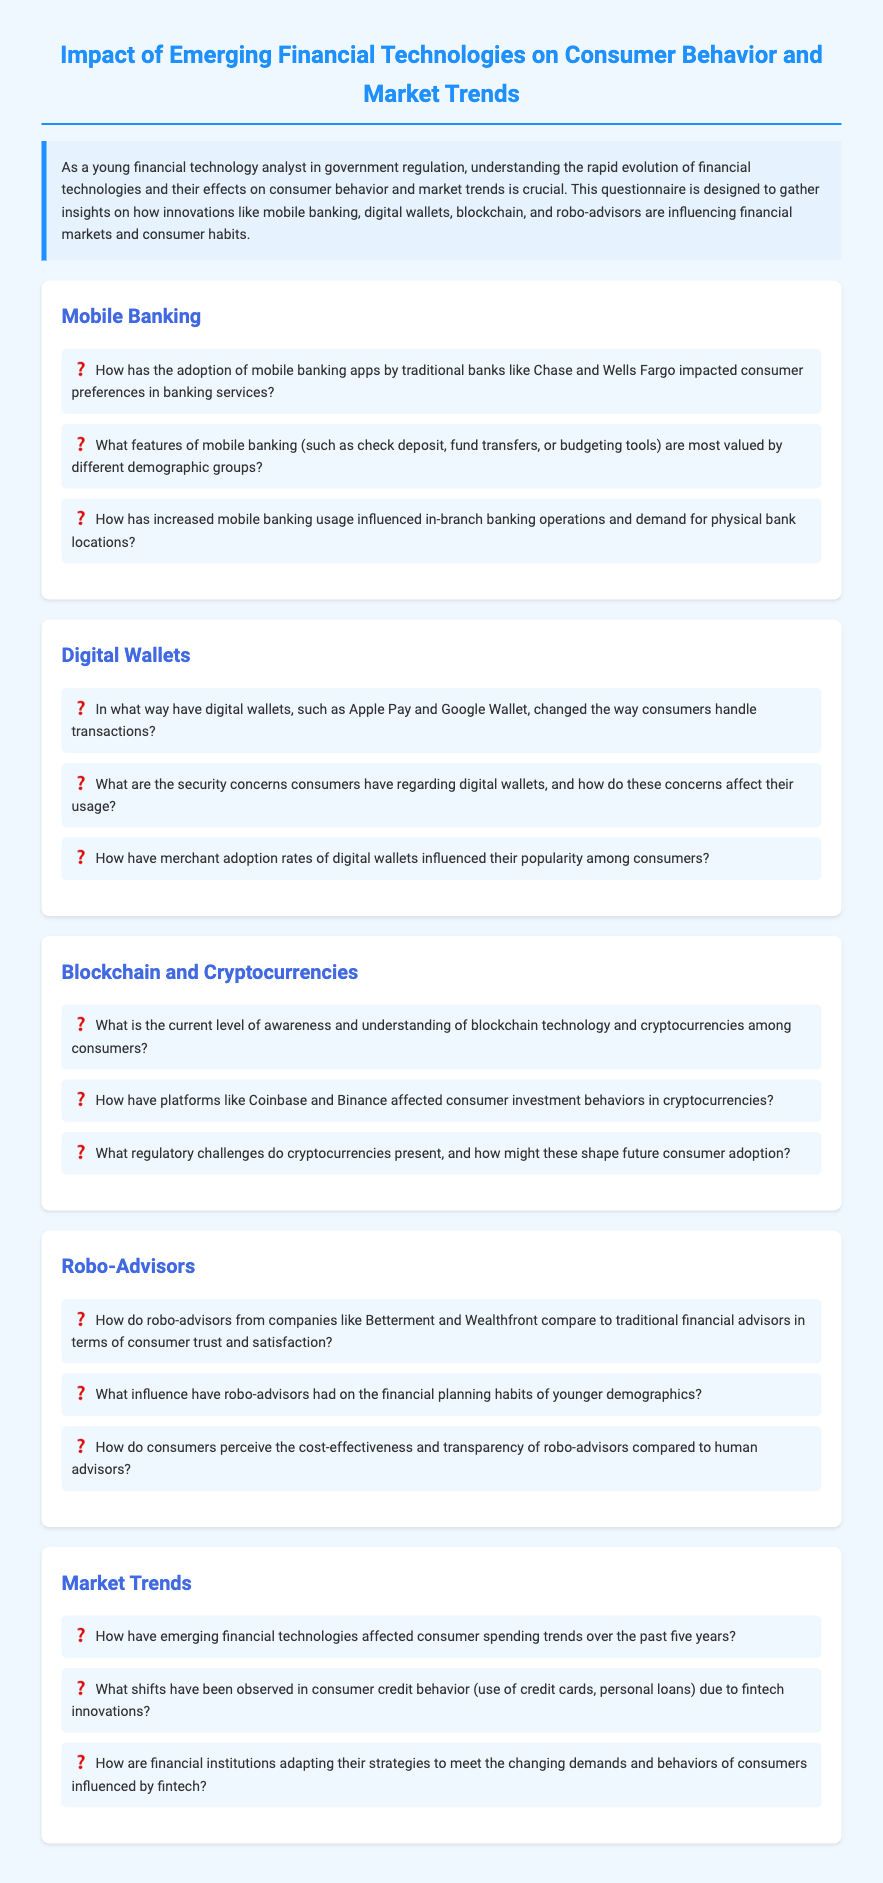How has mobile banking affected consumer preferences? This question seeks to understand the impact of mobile banking on the choices consumers make in banking services, as mentioned in the mobile banking section.
Answer: Consumer preferences What demographic groups value mobile banking features the most? This question asks for the specific demographics that prioritize certain features of mobile banking, as highlighted in the mobile banking section.
Answer: Different demographic groups What influence do digital wallets have on transaction handling? This question looks for the specific changes in how transactions are managed due to digital wallets, as discussed in the digital wallets section.
Answer: Changed the way consumers handle transactions What are the primary security concerns regarding digital wallets? This question focuses on identifying the main security issues consumers face with digital wallets, as outlined in the digital wallets section.
Answer: Security concerns How has consumer awareness of cryptocurrencies changed? This question asks for insights on consumer understanding of blockchain technology and cryptocurrencies from the blockchain and cryptocurrencies section.
Answer: Current level of awareness What impact do platforms like Coinbase have on investment behaviors? This question seeks to find out how certain platforms influence consumer behavior in cryptocurrency investments, as mentioned in the blockchain and cryptocurrencies section.
Answer: Affected investment behaviors How do robo-advisors compare to traditional advisors? This question aims to uncover the comparison of robo-advisors to human advisors in terms of trust and satisfaction, as noted in the robo-advisors section.
Answer: Compare to traditional financial advisors What effect have fintech innovations had on consumer credit behavior? This question inquires about the changes in consumer credit behavior due to financial technology, according to the market trends section.
Answer: Shifts observed in consumer credit behavior How have emerging financial technologies influenced consumer spending trends? This question looks for the specific effects of fintech on spending patterns over the last five years, as discussed in the market trends section.
Answer: Affected consumer spending trends 